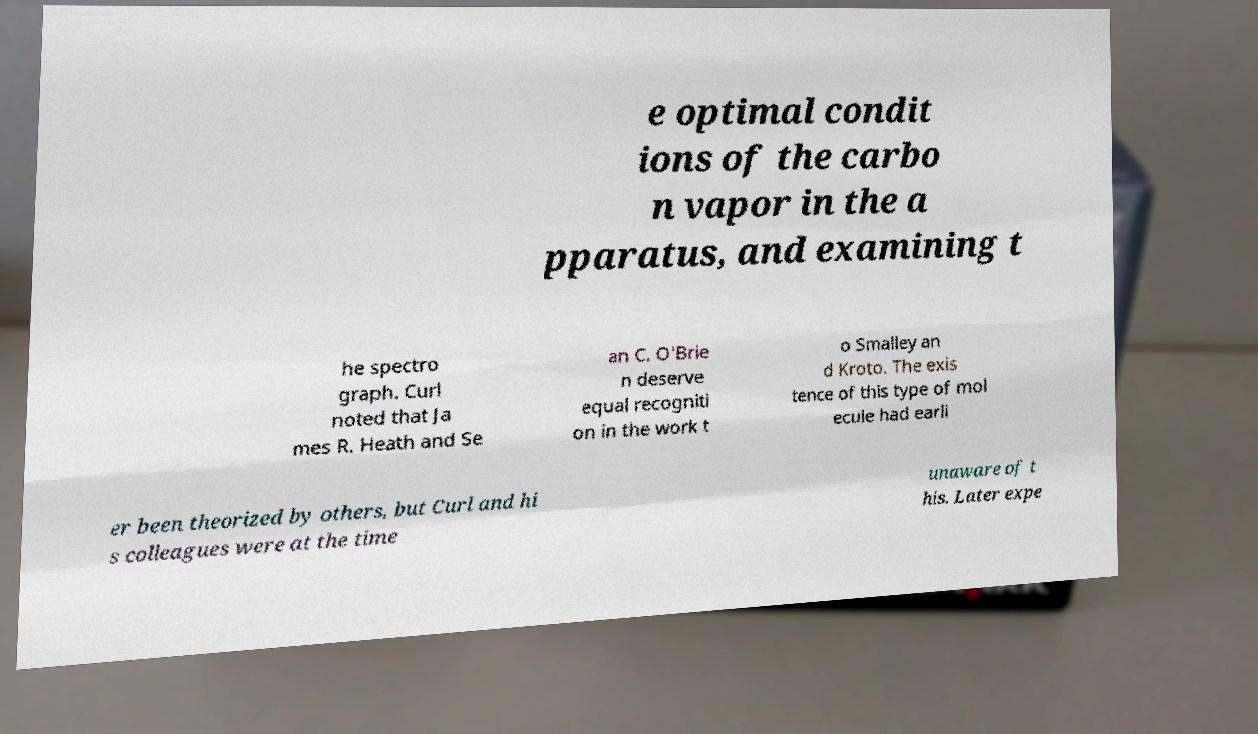Could you extract and type out the text from this image? e optimal condit ions of the carbo n vapor in the a pparatus, and examining t he spectro graph. Curl noted that Ja mes R. Heath and Se an C. O'Brie n deserve equal recogniti on in the work t o Smalley an d Kroto. The exis tence of this type of mol ecule had earli er been theorized by others, but Curl and hi s colleagues were at the time unaware of t his. Later expe 